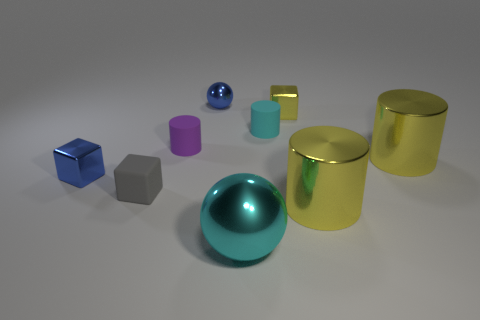Subtract all tiny purple rubber cylinders. How many cylinders are left? 3 Subtract all cyan cylinders. How many cylinders are left? 3 Add 1 tiny cyan matte things. How many objects exist? 10 Subtract all blue cylinders. Subtract all brown spheres. How many cylinders are left? 4 Subtract all cylinders. How many objects are left? 5 Add 1 small blue things. How many small blue things exist? 3 Subtract 0 gray spheres. How many objects are left? 9 Subtract all small yellow cylinders. Subtract all blue metal things. How many objects are left? 7 Add 3 purple things. How many purple things are left? 4 